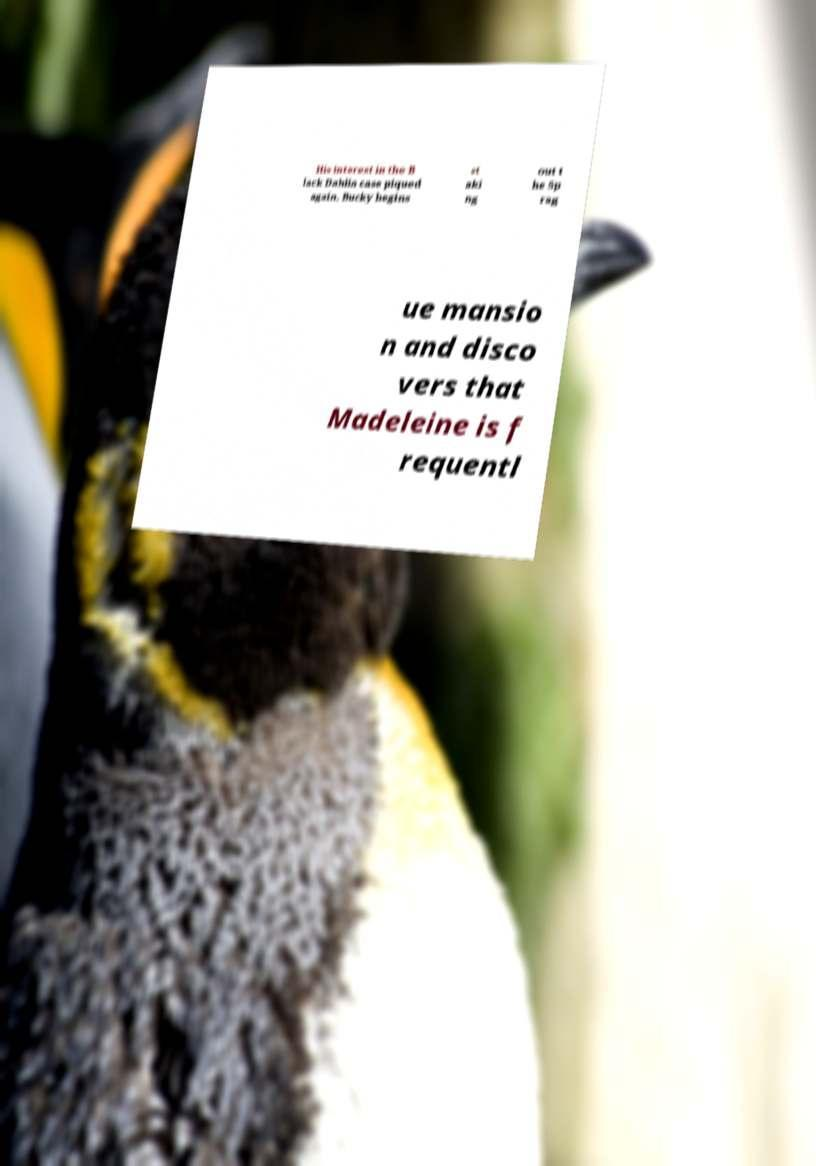There's text embedded in this image that I need extracted. Can you transcribe it verbatim? His interest in the B lack Dahlia case piqued again, Bucky begins st aki ng out t he Sp rag ue mansio n and disco vers that Madeleine is f requentl 